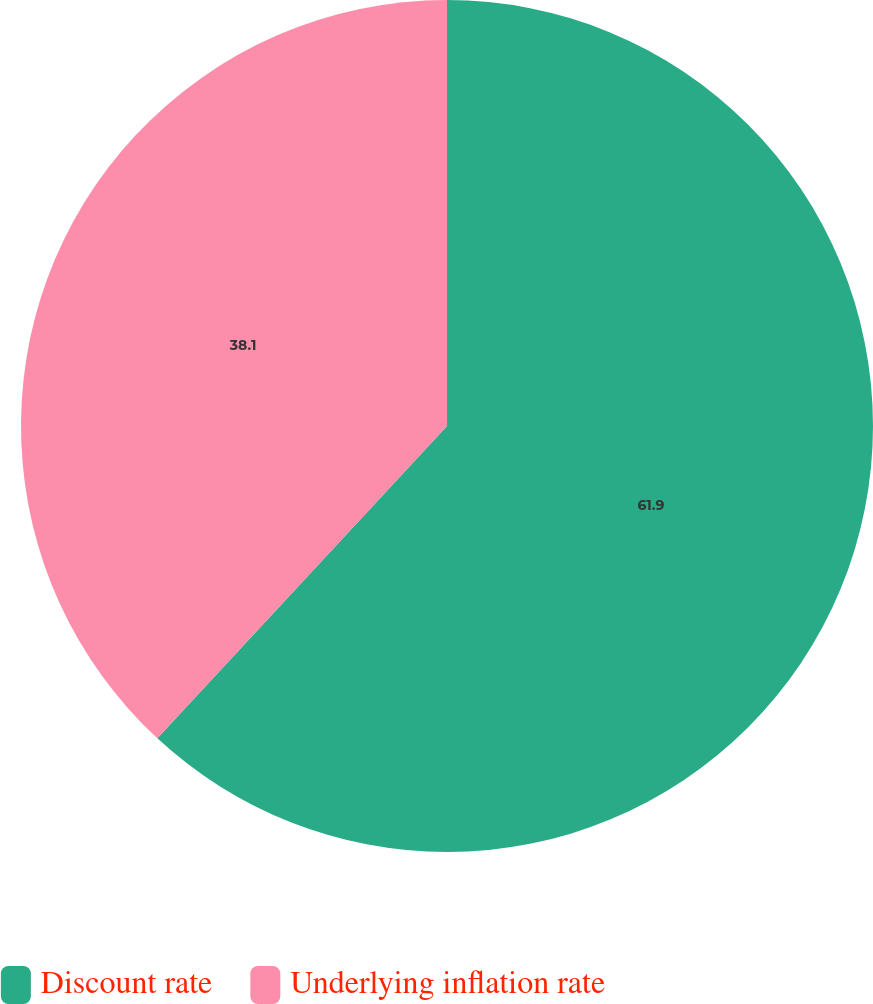<chart> <loc_0><loc_0><loc_500><loc_500><pie_chart><fcel>Discount rate<fcel>Underlying inflation rate<nl><fcel>61.9%<fcel>38.1%<nl></chart> 